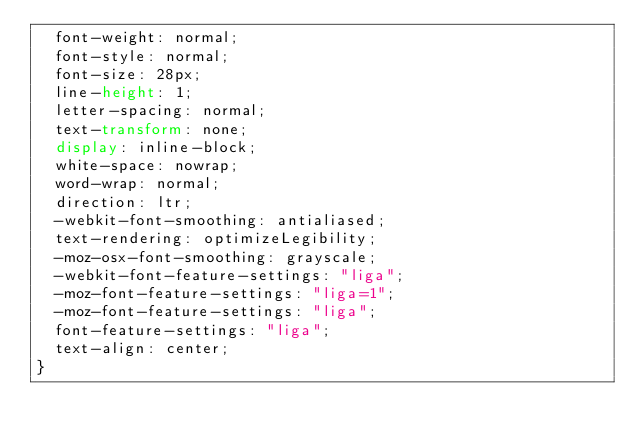<code> <loc_0><loc_0><loc_500><loc_500><_CSS_>  font-weight: normal;
  font-style: normal;
  font-size: 28px;
  line-height: 1;
  letter-spacing: normal;
  text-transform: none;
  display: inline-block;
  white-space: nowrap;
  word-wrap: normal;
  direction: ltr;
  -webkit-font-smoothing: antialiased;
  text-rendering: optimizeLegibility;
  -moz-osx-font-smoothing: grayscale;
  -webkit-font-feature-settings: "liga";
  -moz-font-feature-settings: "liga=1";
  -moz-font-feature-settings: "liga";
  font-feature-settings: "liga";
  text-align: center;
}
</code> 